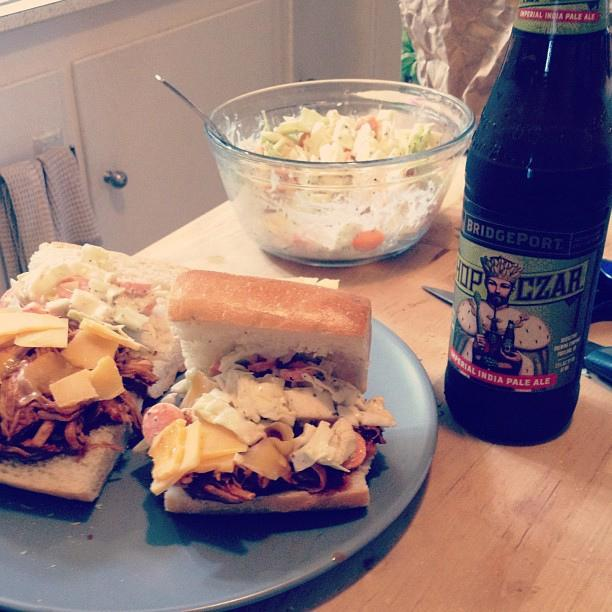Where was this food made? kitchen 